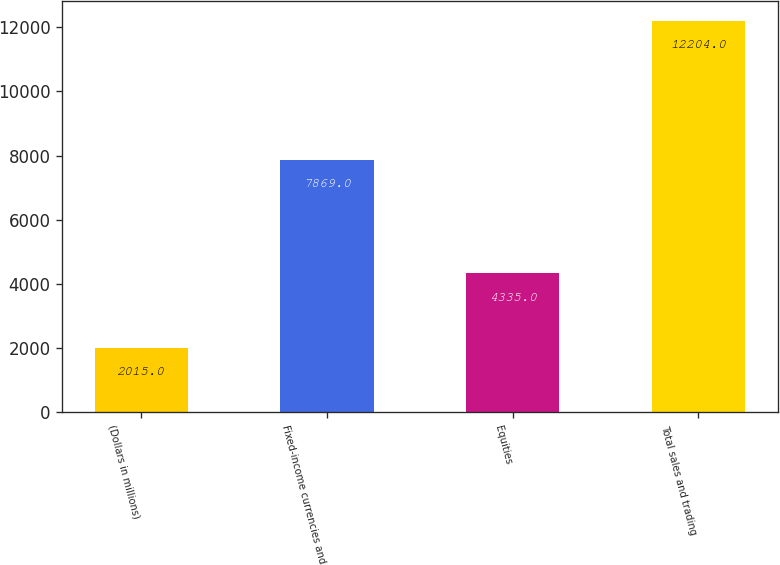Convert chart. <chart><loc_0><loc_0><loc_500><loc_500><bar_chart><fcel>(Dollars in millions)<fcel>Fixed-income currencies and<fcel>Equities<fcel>Total sales and trading<nl><fcel>2015<fcel>7869<fcel>4335<fcel>12204<nl></chart> 